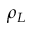Convert formula to latex. <formula><loc_0><loc_0><loc_500><loc_500>\rho _ { L }</formula> 